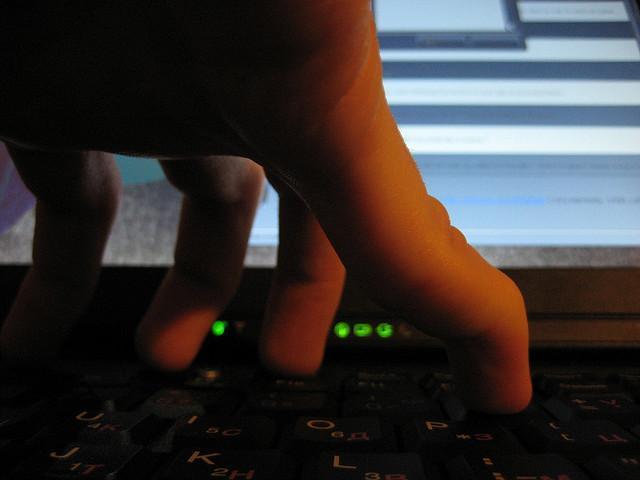How many keyboards are visible?
Give a very brief answer. 1. 